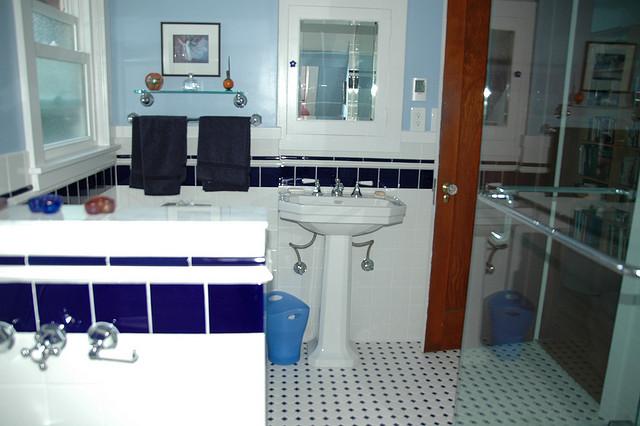What color is the floor?
Short answer required. White and black. How many sinks are in the bathroom?
Give a very brief answer. 1. Is there a carpet on the floor?
Answer briefly. No. Is the window open?
Concise answer only. Yes. 